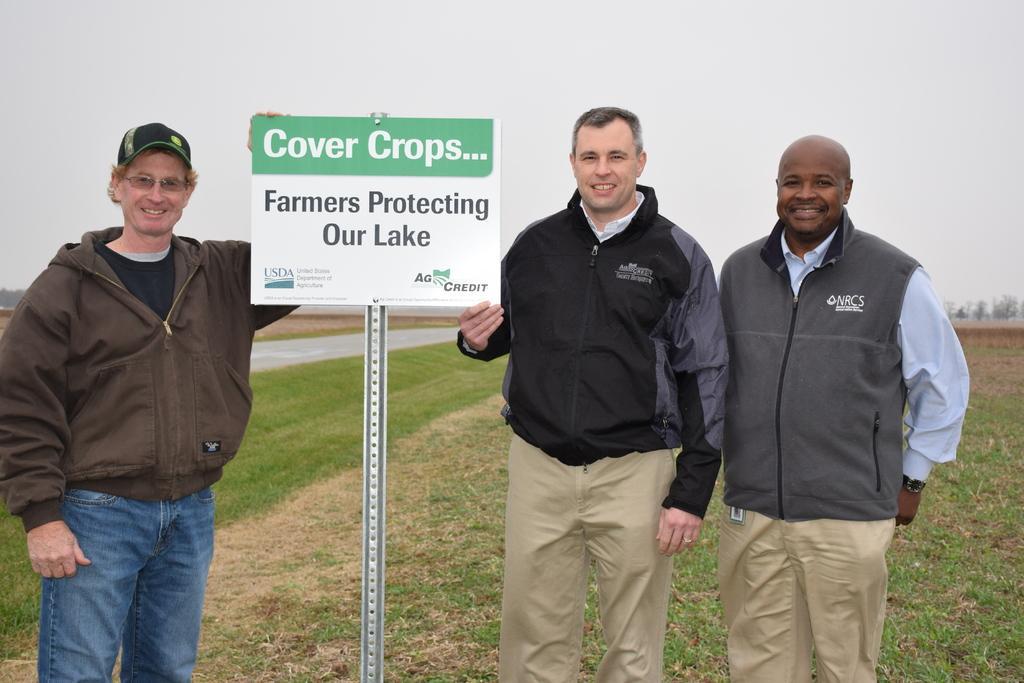Describe this image in one or two sentences. In this picture we can see few people, they are all smiling, on the left side of the image we can see a man, he wore spectacles and a cap, beside him we can find a board and a metal rod, in the background we can see grass and few trees. 